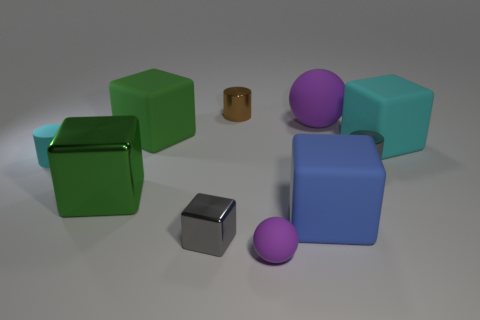Subtract all small cubes. How many cubes are left? 4 Subtract all gray cylinders. How many green blocks are left? 2 Subtract all green cubes. How many cubes are left? 3 Subtract 2 cubes. How many cubes are left? 3 Subtract all purple cubes. Subtract all brown cylinders. How many cubes are left? 5 Subtract all spheres. How many objects are left? 8 Subtract all red rubber cylinders. Subtract all tiny matte cylinders. How many objects are left? 9 Add 1 big cyan matte blocks. How many big cyan matte blocks are left? 2 Add 3 large blue metallic objects. How many large blue metallic objects exist? 3 Subtract 1 brown cylinders. How many objects are left? 9 